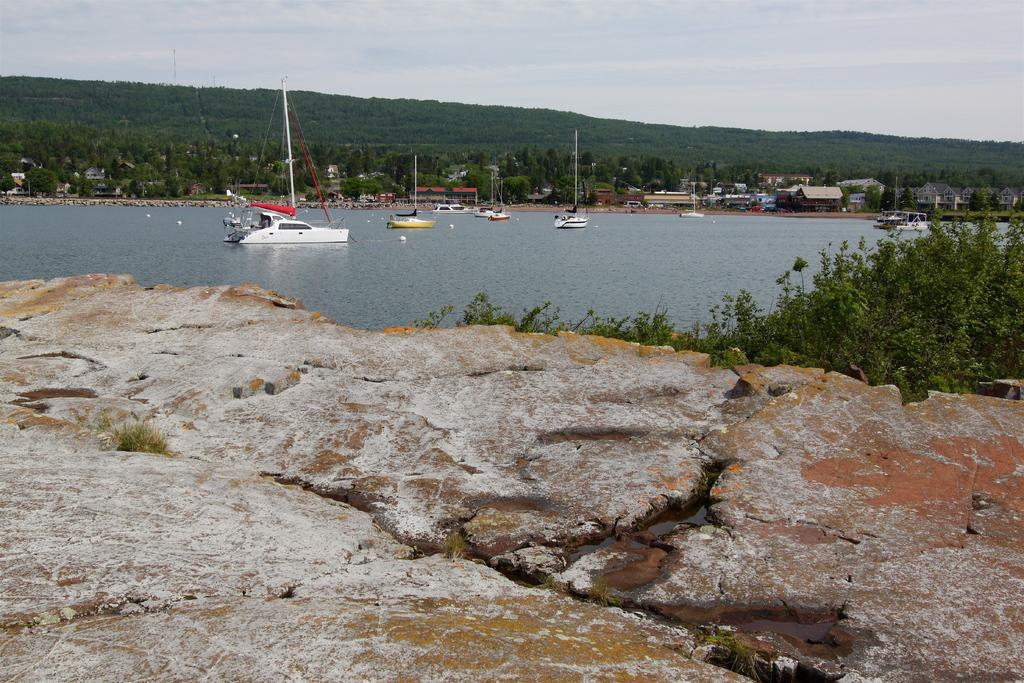What is on the water in the image? There are boats on the water in the image. What can be seen in the background of the image? There are trees, buildings, and hills in the background of the image. What grade does the hand receive on the board in the image? There is no hand or board present in the image; it features boats on the water and background elements such as trees, buildings, and hills. 